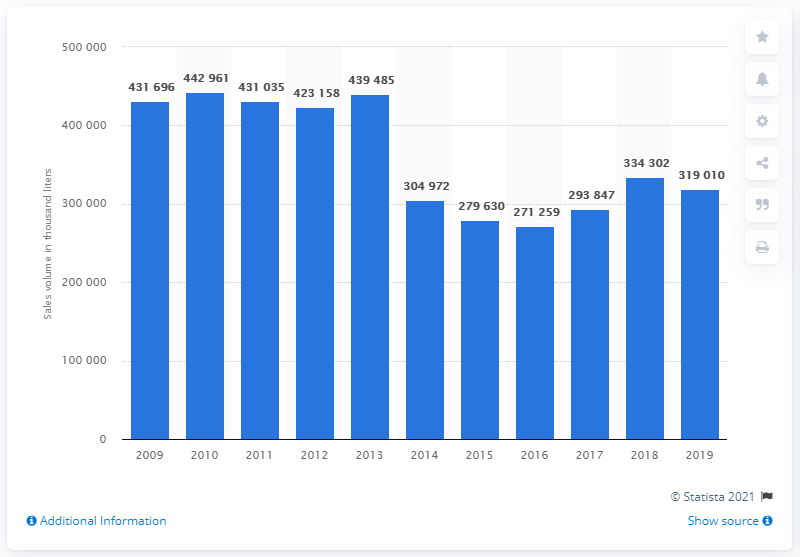Identify some key points in this picture. The sales of ice cream fell from 2013 to 2014, with a decline of 319,010 units. In 2019, the sales volume of ice cream in the UK was approximately 319,010 units. 